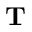Convert formula to latex. <formula><loc_0><loc_0><loc_500><loc_500>\mathbf T</formula> 